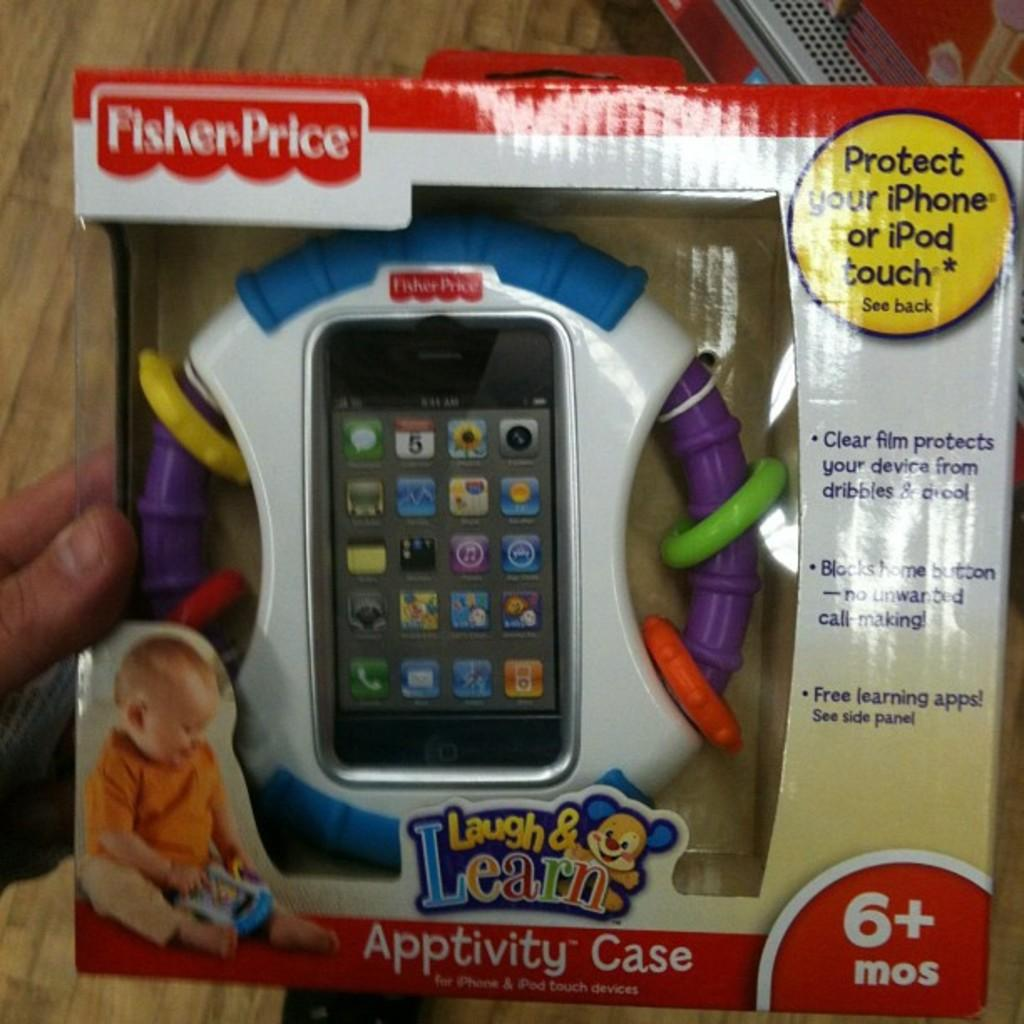<image>
Relay a brief, clear account of the picture shown. A Fisher Price brand Laugh & Learn toy phone with apps for children age 6+ is pictured. 